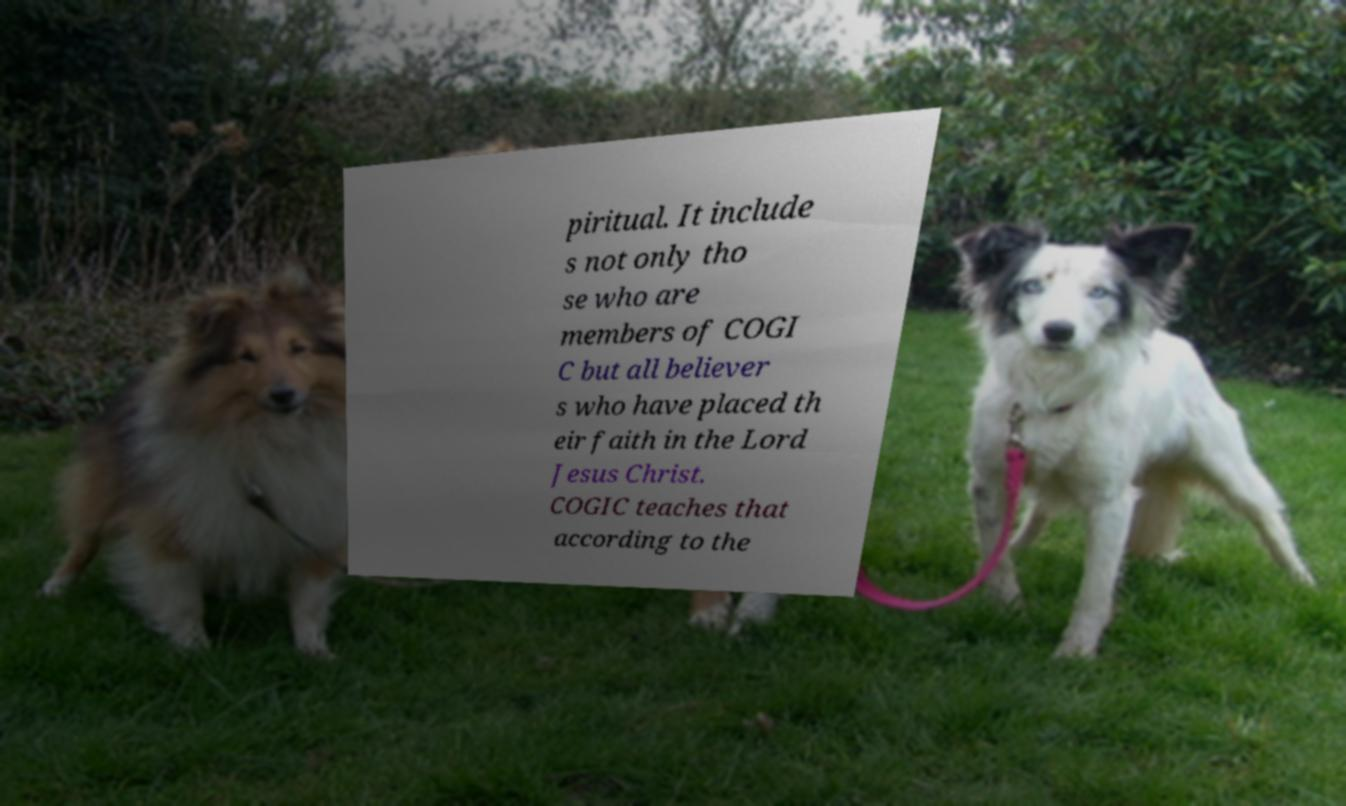I need the written content from this picture converted into text. Can you do that? piritual. It include s not only tho se who are members of COGI C but all believer s who have placed th eir faith in the Lord Jesus Christ. COGIC teaches that according to the 